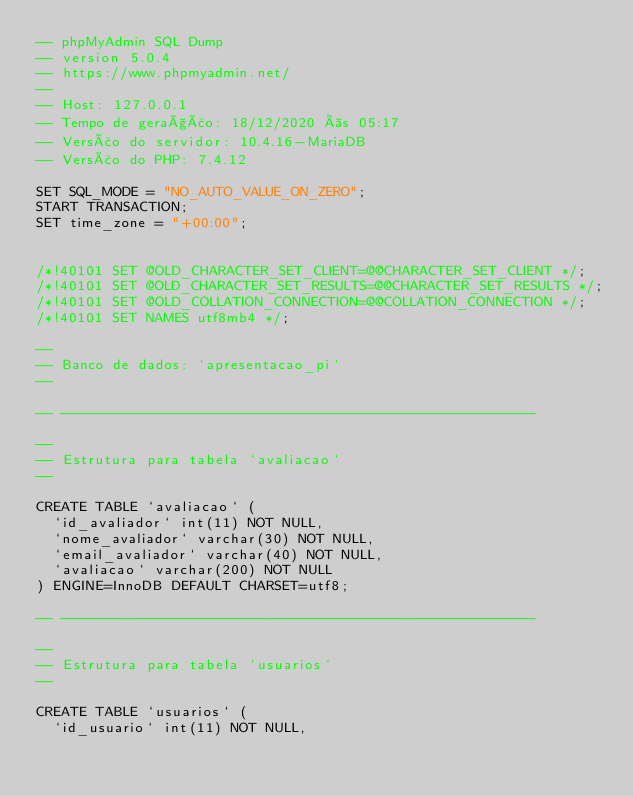<code> <loc_0><loc_0><loc_500><loc_500><_SQL_>-- phpMyAdmin SQL Dump
-- version 5.0.4
-- https://www.phpmyadmin.net/
--
-- Host: 127.0.0.1
-- Tempo de geração: 18/12/2020 às 05:17
-- Versão do servidor: 10.4.16-MariaDB
-- Versão do PHP: 7.4.12

SET SQL_MODE = "NO_AUTO_VALUE_ON_ZERO";
START TRANSACTION;
SET time_zone = "+00:00";


/*!40101 SET @OLD_CHARACTER_SET_CLIENT=@@CHARACTER_SET_CLIENT */;
/*!40101 SET @OLD_CHARACTER_SET_RESULTS=@@CHARACTER_SET_RESULTS */;
/*!40101 SET @OLD_COLLATION_CONNECTION=@@COLLATION_CONNECTION */;
/*!40101 SET NAMES utf8mb4 */;

--
-- Banco de dados: `apresentacao_pi`
--

-- --------------------------------------------------------

--
-- Estrutura para tabela `avaliacao`
--

CREATE TABLE `avaliacao` (
  `id_avaliador` int(11) NOT NULL,
  `nome_avaliador` varchar(30) NOT NULL,
  `email_avaliador` varchar(40) NOT NULL,
  `avaliacao` varchar(200) NOT NULL
) ENGINE=InnoDB DEFAULT CHARSET=utf8;

-- --------------------------------------------------------

--
-- Estrutura para tabela `usuarios`
--

CREATE TABLE `usuarios` (
  `id_usuario` int(11) NOT NULL,</code> 